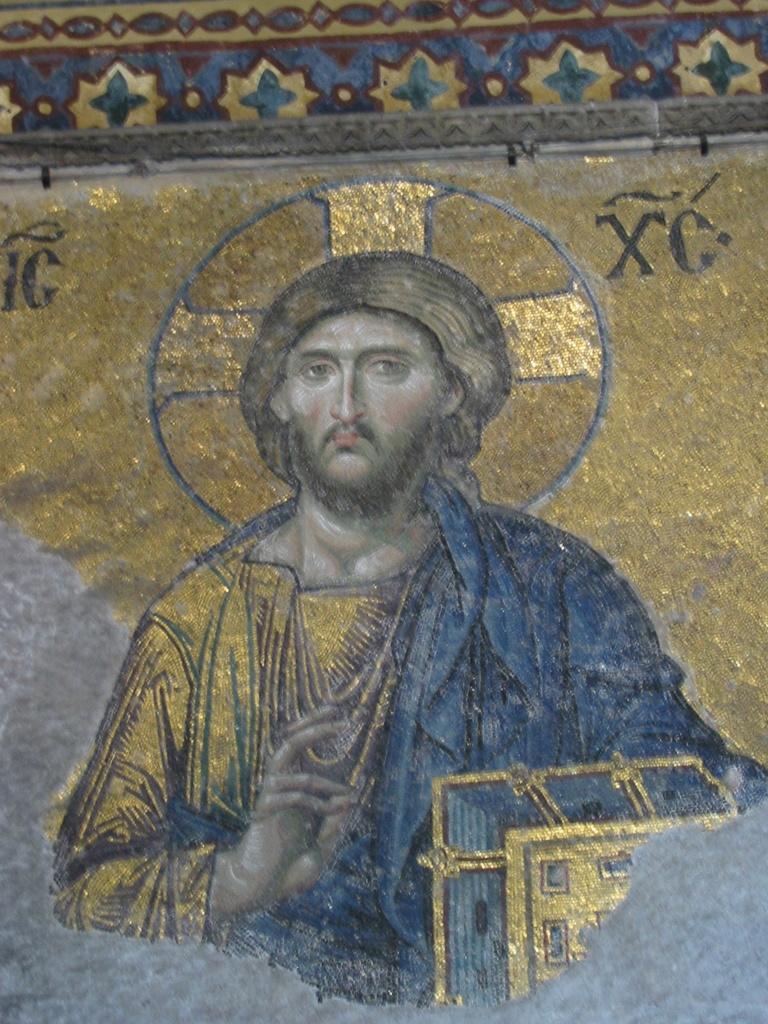Can you describe this image briefly? In this image there is the picture of Jesus Christ. 